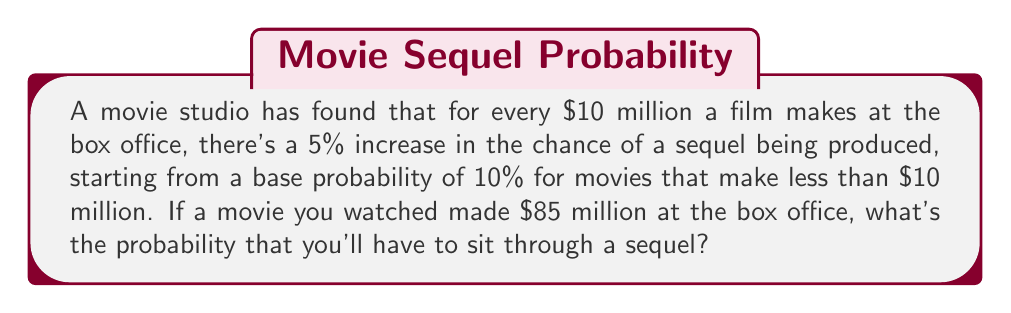Can you solve this math problem? Let's approach this step-by-step:

1) First, we need to determine how many $10 million increments are in $85 million:
   $\frac{85}{10} = 8.5$

2) Each full $10 million increment increases the probability by 5%. There are 8 full increments, so:
   $8 \times 5\% = 40\%$ increase

3) The base probability is 10%, so we add this to our increase:
   $10\% + 40\% = 50\%$

4) However, we still have 0.5 of an increment left (the $5 million). This contributes half of a 5% increase:
   $0.5 \times 5\% = 2.5\%$

5) Adding this to our current probability:
   $50\% + 2.5\% = 52.5\%$

Therefore, the probability of a sequel being produced is 52.5% or 0.525.
Answer: 0.525 